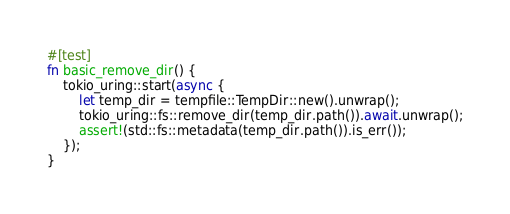<code> <loc_0><loc_0><loc_500><loc_500><_Rust_>#[test]
fn basic_remove_dir() {
    tokio_uring::start(async {
        let temp_dir = tempfile::TempDir::new().unwrap();
        tokio_uring::fs::remove_dir(temp_dir.path()).await.unwrap();
        assert!(std::fs::metadata(temp_dir.path()).is_err());
    });
}
</code> 